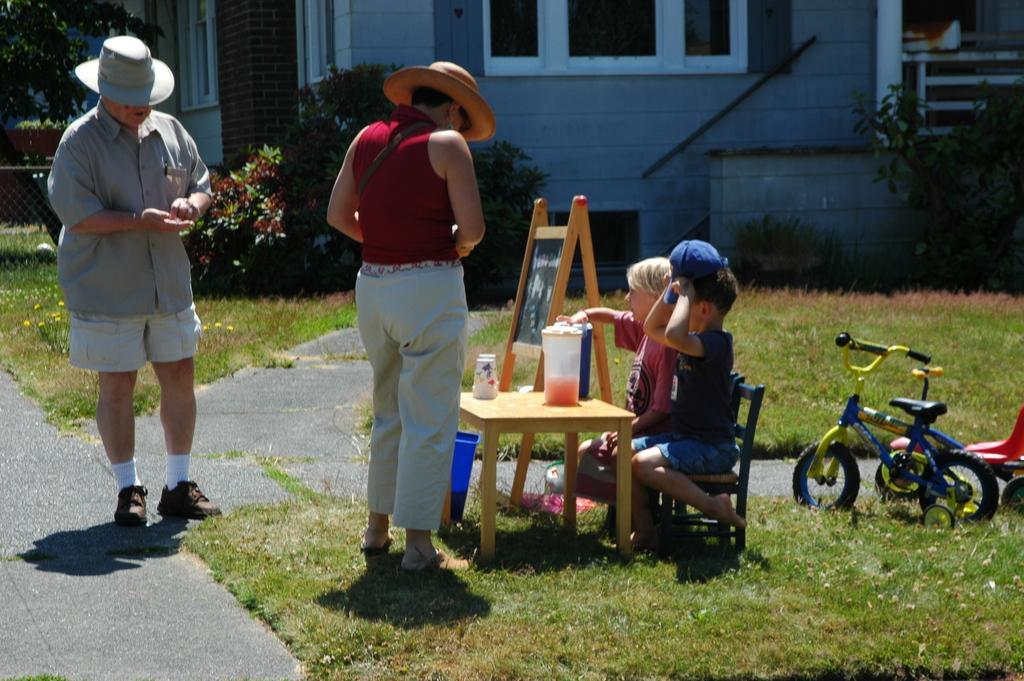Please provide a concise description of this image. In this image there are two persons standing, there are two persons sitting, there are persons holding an object, there are chairs, there is a table, there are objects on the table, there is a board, there is text on the board, there are bicycles, there are grass truncated towards the right of the image, truncated towards the bottom of the image, there is road truncated towards the bottom of the image, there is road truncated towards the left of the image, there is grass truncated towards the left of the image, there is tree truncated towards the left of the image, there is a fencing truncated towards the top of the image, there is wall truncated towards the top of the image, there are windows truncated towards the top of the image, there is a tree truncated towards the right of the image. 